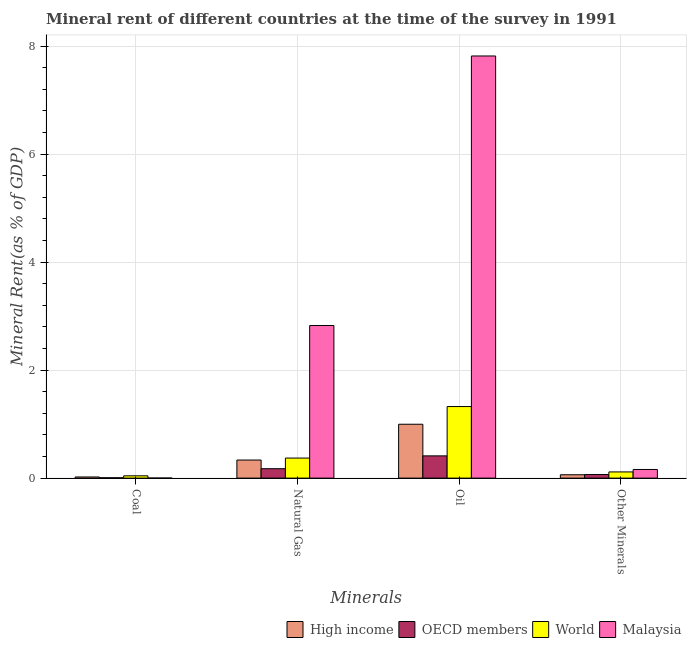How many groups of bars are there?
Give a very brief answer. 4. What is the label of the 3rd group of bars from the left?
Offer a terse response. Oil. What is the  rent of other minerals in World?
Offer a terse response. 0.11. Across all countries, what is the maximum  rent of other minerals?
Offer a terse response. 0.16. Across all countries, what is the minimum coal rent?
Your answer should be very brief. 0. What is the total  rent of other minerals in the graph?
Offer a very short reply. 0.4. What is the difference between the  rent of other minerals in OECD members and that in Malaysia?
Make the answer very short. -0.09. What is the difference between the natural gas rent in High income and the oil rent in World?
Keep it short and to the point. -0.99. What is the average natural gas rent per country?
Provide a succinct answer. 0.93. What is the difference between the coal rent and natural gas rent in World?
Keep it short and to the point. -0.33. What is the ratio of the coal rent in OECD members to that in High income?
Ensure brevity in your answer.  0.32. Is the natural gas rent in OECD members less than that in High income?
Your answer should be compact. Yes. Is the difference between the oil rent in OECD members and World greater than the difference between the  rent of other minerals in OECD members and World?
Ensure brevity in your answer.  No. What is the difference between the highest and the second highest coal rent?
Your answer should be very brief. 0.02. What is the difference between the highest and the lowest oil rent?
Offer a terse response. 7.41. Is the sum of the coal rent in OECD members and World greater than the maximum oil rent across all countries?
Offer a terse response. No. What does the 2nd bar from the right in Coal represents?
Your answer should be compact. World. Is it the case that in every country, the sum of the coal rent and natural gas rent is greater than the oil rent?
Keep it short and to the point. No. How many bars are there?
Provide a succinct answer. 16. How many countries are there in the graph?
Your answer should be very brief. 4. What is the difference between two consecutive major ticks on the Y-axis?
Your response must be concise. 2. Does the graph contain grids?
Provide a short and direct response. Yes. How are the legend labels stacked?
Provide a succinct answer. Horizontal. What is the title of the graph?
Your answer should be compact. Mineral rent of different countries at the time of the survey in 1991. Does "Mongolia" appear as one of the legend labels in the graph?
Provide a succinct answer. No. What is the label or title of the X-axis?
Offer a terse response. Minerals. What is the label or title of the Y-axis?
Ensure brevity in your answer.  Mineral Rent(as % of GDP). What is the Mineral Rent(as % of GDP) in High income in Coal?
Offer a very short reply. 0.02. What is the Mineral Rent(as % of GDP) of OECD members in Coal?
Your answer should be very brief. 0.01. What is the Mineral Rent(as % of GDP) in World in Coal?
Provide a short and direct response. 0.04. What is the Mineral Rent(as % of GDP) of Malaysia in Coal?
Give a very brief answer. 0. What is the Mineral Rent(as % of GDP) in High income in Natural Gas?
Offer a terse response. 0.33. What is the Mineral Rent(as % of GDP) of OECD members in Natural Gas?
Give a very brief answer. 0.17. What is the Mineral Rent(as % of GDP) in World in Natural Gas?
Keep it short and to the point. 0.37. What is the Mineral Rent(as % of GDP) in Malaysia in Natural Gas?
Your answer should be compact. 2.83. What is the Mineral Rent(as % of GDP) of High income in Oil?
Make the answer very short. 1. What is the Mineral Rent(as % of GDP) of OECD members in Oil?
Your answer should be compact. 0.41. What is the Mineral Rent(as % of GDP) of World in Oil?
Make the answer very short. 1.33. What is the Mineral Rent(as % of GDP) in Malaysia in Oil?
Give a very brief answer. 7.82. What is the Mineral Rent(as % of GDP) in High income in Other Minerals?
Your response must be concise. 0.06. What is the Mineral Rent(as % of GDP) in OECD members in Other Minerals?
Provide a succinct answer. 0.07. What is the Mineral Rent(as % of GDP) of World in Other Minerals?
Offer a terse response. 0.11. What is the Mineral Rent(as % of GDP) in Malaysia in Other Minerals?
Your answer should be very brief. 0.16. Across all Minerals, what is the maximum Mineral Rent(as % of GDP) in High income?
Ensure brevity in your answer.  1. Across all Minerals, what is the maximum Mineral Rent(as % of GDP) in OECD members?
Ensure brevity in your answer.  0.41. Across all Minerals, what is the maximum Mineral Rent(as % of GDP) in World?
Ensure brevity in your answer.  1.33. Across all Minerals, what is the maximum Mineral Rent(as % of GDP) in Malaysia?
Your answer should be compact. 7.82. Across all Minerals, what is the minimum Mineral Rent(as % of GDP) of High income?
Provide a succinct answer. 0.02. Across all Minerals, what is the minimum Mineral Rent(as % of GDP) of OECD members?
Offer a very short reply. 0.01. Across all Minerals, what is the minimum Mineral Rent(as % of GDP) of World?
Your answer should be very brief. 0.04. Across all Minerals, what is the minimum Mineral Rent(as % of GDP) of Malaysia?
Your response must be concise. 0. What is the total Mineral Rent(as % of GDP) in High income in the graph?
Provide a short and direct response. 1.42. What is the total Mineral Rent(as % of GDP) in OECD members in the graph?
Offer a terse response. 0.66. What is the total Mineral Rent(as % of GDP) of World in the graph?
Provide a succinct answer. 1.85. What is the total Mineral Rent(as % of GDP) of Malaysia in the graph?
Make the answer very short. 10.81. What is the difference between the Mineral Rent(as % of GDP) in High income in Coal and that in Natural Gas?
Ensure brevity in your answer.  -0.31. What is the difference between the Mineral Rent(as % of GDP) in OECD members in Coal and that in Natural Gas?
Offer a very short reply. -0.17. What is the difference between the Mineral Rent(as % of GDP) in World in Coal and that in Natural Gas?
Provide a short and direct response. -0.33. What is the difference between the Mineral Rent(as % of GDP) in Malaysia in Coal and that in Natural Gas?
Ensure brevity in your answer.  -2.83. What is the difference between the Mineral Rent(as % of GDP) of High income in Coal and that in Oil?
Provide a short and direct response. -0.98. What is the difference between the Mineral Rent(as % of GDP) of OECD members in Coal and that in Oil?
Provide a succinct answer. -0.41. What is the difference between the Mineral Rent(as % of GDP) in World in Coal and that in Oil?
Offer a terse response. -1.28. What is the difference between the Mineral Rent(as % of GDP) in Malaysia in Coal and that in Oil?
Offer a terse response. -7.82. What is the difference between the Mineral Rent(as % of GDP) of High income in Coal and that in Other Minerals?
Your answer should be very brief. -0.04. What is the difference between the Mineral Rent(as % of GDP) in OECD members in Coal and that in Other Minerals?
Offer a terse response. -0.06. What is the difference between the Mineral Rent(as % of GDP) of World in Coal and that in Other Minerals?
Your answer should be compact. -0.07. What is the difference between the Mineral Rent(as % of GDP) in Malaysia in Coal and that in Other Minerals?
Your answer should be compact. -0.16. What is the difference between the Mineral Rent(as % of GDP) in High income in Natural Gas and that in Oil?
Your answer should be compact. -0.66. What is the difference between the Mineral Rent(as % of GDP) of OECD members in Natural Gas and that in Oil?
Provide a short and direct response. -0.24. What is the difference between the Mineral Rent(as % of GDP) in World in Natural Gas and that in Oil?
Your answer should be compact. -0.95. What is the difference between the Mineral Rent(as % of GDP) in Malaysia in Natural Gas and that in Oil?
Make the answer very short. -4.99. What is the difference between the Mineral Rent(as % of GDP) in High income in Natural Gas and that in Other Minerals?
Make the answer very short. 0.27. What is the difference between the Mineral Rent(as % of GDP) of OECD members in Natural Gas and that in Other Minerals?
Provide a succinct answer. 0.11. What is the difference between the Mineral Rent(as % of GDP) in World in Natural Gas and that in Other Minerals?
Give a very brief answer. 0.26. What is the difference between the Mineral Rent(as % of GDP) in Malaysia in Natural Gas and that in Other Minerals?
Keep it short and to the point. 2.67. What is the difference between the Mineral Rent(as % of GDP) of High income in Oil and that in Other Minerals?
Make the answer very short. 0.94. What is the difference between the Mineral Rent(as % of GDP) in OECD members in Oil and that in Other Minerals?
Your answer should be very brief. 0.35. What is the difference between the Mineral Rent(as % of GDP) of World in Oil and that in Other Minerals?
Give a very brief answer. 1.21. What is the difference between the Mineral Rent(as % of GDP) of Malaysia in Oil and that in Other Minerals?
Keep it short and to the point. 7.66. What is the difference between the Mineral Rent(as % of GDP) of High income in Coal and the Mineral Rent(as % of GDP) of OECD members in Natural Gas?
Keep it short and to the point. -0.15. What is the difference between the Mineral Rent(as % of GDP) of High income in Coal and the Mineral Rent(as % of GDP) of World in Natural Gas?
Offer a very short reply. -0.35. What is the difference between the Mineral Rent(as % of GDP) of High income in Coal and the Mineral Rent(as % of GDP) of Malaysia in Natural Gas?
Provide a short and direct response. -2.81. What is the difference between the Mineral Rent(as % of GDP) of OECD members in Coal and the Mineral Rent(as % of GDP) of World in Natural Gas?
Your answer should be compact. -0.36. What is the difference between the Mineral Rent(as % of GDP) in OECD members in Coal and the Mineral Rent(as % of GDP) in Malaysia in Natural Gas?
Provide a short and direct response. -2.82. What is the difference between the Mineral Rent(as % of GDP) in World in Coal and the Mineral Rent(as % of GDP) in Malaysia in Natural Gas?
Ensure brevity in your answer.  -2.78. What is the difference between the Mineral Rent(as % of GDP) of High income in Coal and the Mineral Rent(as % of GDP) of OECD members in Oil?
Ensure brevity in your answer.  -0.39. What is the difference between the Mineral Rent(as % of GDP) in High income in Coal and the Mineral Rent(as % of GDP) in World in Oil?
Keep it short and to the point. -1.3. What is the difference between the Mineral Rent(as % of GDP) in High income in Coal and the Mineral Rent(as % of GDP) in Malaysia in Oil?
Ensure brevity in your answer.  -7.8. What is the difference between the Mineral Rent(as % of GDP) of OECD members in Coal and the Mineral Rent(as % of GDP) of World in Oil?
Keep it short and to the point. -1.32. What is the difference between the Mineral Rent(as % of GDP) of OECD members in Coal and the Mineral Rent(as % of GDP) of Malaysia in Oil?
Ensure brevity in your answer.  -7.81. What is the difference between the Mineral Rent(as % of GDP) of World in Coal and the Mineral Rent(as % of GDP) of Malaysia in Oil?
Your answer should be compact. -7.78. What is the difference between the Mineral Rent(as % of GDP) in High income in Coal and the Mineral Rent(as % of GDP) in OECD members in Other Minerals?
Provide a short and direct response. -0.05. What is the difference between the Mineral Rent(as % of GDP) of High income in Coal and the Mineral Rent(as % of GDP) of World in Other Minerals?
Make the answer very short. -0.09. What is the difference between the Mineral Rent(as % of GDP) of High income in Coal and the Mineral Rent(as % of GDP) of Malaysia in Other Minerals?
Give a very brief answer. -0.14. What is the difference between the Mineral Rent(as % of GDP) in OECD members in Coal and the Mineral Rent(as % of GDP) in World in Other Minerals?
Provide a short and direct response. -0.11. What is the difference between the Mineral Rent(as % of GDP) in OECD members in Coal and the Mineral Rent(as % of GDP) in Malaysia in Other Minerals?
Ensure brevity in your answer.  -0.15. What is the difference between the Mineral Rent(as % of GDP) of World in Coal and the Mineral Rent(as % of GDP) of Malaysia in Other Minerals?
Your answer should be compact. -0.12. What is the difference between the Mineral Rent(as % of GDP) of High income in Natural Gas and the Mineral Rent(as % of GDP) of OECD members in Oil?
Keep it short and to the point. -0.08. What is the difference between the Mineral Rent(as % of GDP) of High income in Natural Gas and the Mineral Rent(as % of GDP) of World in Oil?
Give a very brief answer. -0.99. What is the difference between the Mineral Rent(as % of GDP) of High income in Natural Gas and the Mineral Rent(as % of GDP) of Malaysia in Oil?
Your answer should be compact. -7.48. What is the difference between the Mineral Rent(as % of GDP) of OECD members in Natural Gas and the Mineral Rent(as % of GDP) of World in Oil?
Offer a very short reply. -1.15. What is the difference between the Mineral Rent(as % of GDP) of OECD members in Natural Gas and the Mineral Rent(as % of GDP) of Malaysia in Oil?
Provide a succinct answer. -7.64. What is the difference between the Mineral Rent(as % of GDP) of World in Natural Gas and the Mineral Rent(as % of GDP) of Malaysia in Oil?
Give a very brief answer. -7.45. What is the difference between the Mineral Rent(as % of GDP) of High income in Natural Gas and the Mineral Rent(as % of GDP) of OECD members in Other Minerals?
Provide a succinct answer. 0.27. What is the difference between the Mineral Rent(as % of GDP) of High income in Natural Gas and the Mineral Rent(as % of GDP) of World in Other Minerals?
Offer a terse response. 0.22. What is the difference between the Mineral Rent(as % of GDP) of High income in Natural Gas and the Mineral Rent(as % of GDP) of Malaysia in Other Minerals?
Your response must be concise. 0.17. What is the difference between the Mineral Rent(as % of GDP) in OECD members in Natural Gas and the Mineral Rent(as % of GDP) in World in Other Minerals?
Provide a short and direct response. 0.06. What is the difference between the Mineral Rent(as % of GDP) of OECD members in Natural Gas and the Mineral Rent(as % of GDP) of Malaysia in Other Minerals?
Your answer should be compact. 0.01. What is the difference between the Mineral Rent(as % of GDP) in World in Natural Gas and the Mineral Rent(as % of GDP) in Malaysia in Other Minerals?
Your answer should be compact. 0.21. What is the difference between the Mineral Rent(as % of GDP) of High income in Oil and the Mineral Rent(as % of GDP) of OECD members in Other Minerals?
Ensure brevity in your answer.  0.93. What is the difference between the Mineral Rent(as % of GDP) in High income in Oil and the Mineral Rent(as % of GDP) in World in Other Minerals?
Give a very brief answer. 0.88. What is the difference between the Mineral Rent(as % of GDP) in High income in Oil and the Mineral Rent(as % of GDP) in Malaysia in Other Minerals?
Ensure brevity in your answer.  0.84. What is the difference between the Mineral Rent(as % of GDP) in OECD members in Oil and the Mineral Rent(as % of GDP) in World in Other Minerals?
Your answer should be very brief. 0.3. What is the difference between the Mineral Rent(as % of GDP) in OECD members in Oil and the Mineral Rent(as % of GDP) in Malaysia in Other Minerals?
Offer a terse response. 0.25. What is the difference between the Mineral Rent(as % of GDP) of World in Oil and the Mineral Rent(as % of GDP) of Malaysia in Other Minerals?
Provide a succinct answer. 1.17. What is the average Mineral Rent(as % of GDP) of High income per Minerals?
Provide a succinct answer. 0.35. What is the average Mineral Rent(as % of GDP) in OECD members per Minerals?
Your answer should be very brief. 0.16. What is the average Mineral Rent(as % of GDP) in World per Minerals?
Keep it short and to the point. 0.46. What is the average Mineral Rent(as % of GDP) of Malaysia per Minerals?
Provide a short and direct response. 2.7. What is the difference between the Mineral Rent(as % of GDP) of High income and Mineral Rent(as % of GDP) of OECD members in Coal?
Keep it short and to the point. 0.01. What is the difference between the Mineral Rent(as % of GDP) in High income and Mineral Rent(as % of GDP) in World in Coal?
Offer a terse response. -0.02. What is the difference between the Mineral Rent(as % of GDP) of High income and Mineral Rent(as % of GDP) of Malaysia in Coal?
Your answer should be very brief. 0.02. What is the difference between the Mineral Rent(as % of GDP) in OECD members and Mineral Rent(as % of GDP) in World in Coal?
Your answer should be compact. -0.04. What is the difference between the Mineral Rent(as % of GDP) of OECD members and Mineral Rent(as % of GDP) of Malaysia in Coal?
Your response must be concise. 0.01. What is the difference between the Mineral Rent(as % of GDP) of World and Mineral Rent(as % of GDP) of Malaysia in Coal?
Your answer should be very brief. 0.04. What is the difference between the Mineral Rent(as % of GDP) of High income and Mineral Rent(as % of GDP) of OECD members in Natural Gas?
Offer a terse response. 0.16. What is the difference between the Mineral Rent(as % of GDP) in High income and Mineral Rent(as % of GDP) in World in Natural Gas?
Make the answer very short. -0.04. What is the difference between the Mineral Rent(as % of GDP) of High income and Mineral Rent(as % of GDP) of Malaysia in Natural Gas?
Provide a short and direct response. -2.49. What is the difference between the Mineral Rent(as % of GDP) of OECD members and Mineral Rent(as % of GDP) of World in Natural Gas?
Make the answer very short. -0.2. What is the difference between the Mineral Rent(as % of GDP) in OECD members and Mineral Rent(as % of GDP) in Malaysia in Natural Gas?
Provide a succinct answer. -2.65. What is the difference between the Mineral Rent(as % of GDP) of World and Mineral Rent(as % of GDP) of Malaysia in Natural Gas?
Offer a very short reply. -2.46. What is the difference between the Mineral Rent(as % of GDP) in High income and Mineral Rent(as % of GDP) in OECD members in Oil?
Give a very brief answer. 0.59. What is the difference between the Mineral Rent(as % of GDP) of High income and Mineral Rent(as % of GDP) of World in Oil?
Offer a terse response. -0.33. What is the difference between the Mineral Rent(as % of GDP) in High income and Mineral Rent(as % of GDP) in Malaysia in Oil?
Provide a short and direct response. -6.82. What is the difference between the Mineral Rent(as % of GDP) in OECD members and Mineral Rent(as % of GDP) in World in Oil?
Your answer should be very brief. -0.91. What is the difference between the Mineral Rent(as % of GDP) in OECD members and Mineral Rent(as % of GDP) in Malaysia in Oil?
Make the answer very short. -7.41. What is the difference between the Mineral Rent(as % of GDP) in World and Mineral Rent(as % of GDP) in Malaysia in Oil?
Your answer should be compact. -6.49. What is the difference between the Mineral Rent(as % of GDP) of High income and Mineral Rent(as % of GDP) of OECD members in Other Minerals?
Your answer should be very brief. -0. What is the difference between the Mineral Rent(as % of GDP) of High income and Mineral Rent(as % of GDP) of World in Other Minerals?
Give a very brief answer. -0.05. What is the difference between the Mineral Rent(as % of GDP) in High income and Mineral Rent(as % of GDP) in Malaysia in Other Minerals?
Give a very brief answer. -0.1. What is the difference between the Mineral Rent(as % of GDP) in OECD members and Mineral Rent(as % of GDP) in World in Other Minerals?
Offer a terse response. -0.05. What is the difference between the Mineral Rent(as % of GDP) of OECD members and Mineral Rent(as % of GDP) of Malaysia in Other Minerals?
Keep it short and to the point. -0.09. What is the difference between the Mineral Rent(as % of GDP) of World and Mineral Rent(as % of GDP) of Malaysia in Other Minerals?
Your answer should be compact. -0.05. What is the ratio of the Mineral Rent(as % of GDP) in High income in Coal to that in Natural Gas?
Make the answer very short. 0.06. What is the ratio of the Mineral Rent(as % of GDP) in OECD members in Coal to that in Natural Gas?
Provide a short and direct response. 0.04. What is the ratio of the Mineral Rent(as % of GDP) in World in Coal to that in Natural Gas?
Make the answer very short. 0.11. What is the ratio of the Mineral Rent(as % of GDP) of Malaysia in Coal to that in Natural Gas?
Ensure brevity in your answer.  0. What is the ratio of the Mineral Rent(as % of GDP) of High income in Coal to that in Oil?
Give a very brief answer. 0.02. What is the ratio of the Mineral Rent(as % of GDP) in OECD members in Coal to that in Oil?
Keep it short and to the point. 0.02. What is the ratio of the Mineral Rent(as % of GDP) of World in Coal to that in Oil?
Ensure brevity in your answer.  0.03. What is the ratio of the Mineral Rent(as % of GDP) in Malaysia in Coal to that in Oil?
Make the answer very short. 0. What is the ratio of the Mineral Rent(as % of GDP) in High income in Coal to that in Other Minerals?
Provide a short and direct response. 0.34. What is the ratio of the Mineral Rent(as % of GDP) of OECD members in Coal to that in Other Minerals?
Your response must be concise. 0.1. What is the ratio of the Mineral Rent(as % of GDP) of World in Coal to that in Other Minerals?
Provide a short and direct response. 0.37. What is the ratio of the Mineral Rent(as % of GDP) of Malaysia in Coal to that in Other Minerals?
Make the answer very short. 0.01. What is the ratio of the Mineral Rent(as % of GDP) in High income in Natural Gas to that in Oil?
Offer a terse response. 0.34. What is the ratio of the Mineral Rent(as % of GDP) of OECD members in Natural Gas to that in Oil?
Keep it short and to the point. 0.42. What is the ratio of the Mineral Rent(as % of GDP) in World in Natural Gas to that in Oil?
Give a very brief answer. 0.28. What is the ratio of the Mineral Rent(as % of GDP) of Malaysia in Natural Gas to that in Oil?
Provide a succinct answer. 0.36. What is the ratio of the Mineral Rent(as % of GDP) of High income in Natural Gas to that in Other Minerals?
Provide a succinct answer. 5.37. What is the ratio of the Mineral Rent(as % of GDP) in OECD members in Natural Gas to that in Other Minerals?
Your answer should be very brief. 2.64. What is the ratio of the Mineral Rent(as % of GDP) in World in Natural Gas to that in Other Minerals?
Make the answer very short. 3.24. What is the ratio of the Mineral Rent(as % of GDP) of Malaysia in Natural Gas to that in Other Minerals?
Offer a very short reply. 17.66. What is the ratio of the Mineral Rent(as % of GDP) of High income in Oil to that in Other Minerals?
Provide a short and direct response. 16.01. What is the ratio of the Mineral Rent(as % of GDP) in OECD members in Oil to that in Other Minerals?
Provide a succinct answer. 6.23. What is the ratio of the Mineral Rent(as % of GDP) of World in Oil to that in Other Minerals?
Your answer should be very brief. 11.56. What is the ratio of the Mineral Rent(as % of GDP) of Malaysia in Oil to that in Other Minerals?
Your answer should be compact. 48.85. What is the difference between the highest and the second highest Mineral Rent(as % of GDP) of High income?
Ensure brevity in your answer.  0.66. What is the difference between the highest and the second highest Mineral Rent(as % of GDP) in OECD members?
Provide a succinct answer. 0.24. What is the difference between the highest and the second highest Mineral Rent(as % of GDP) in World?
Offer a very short reply. 0.95. What is the difference between the highest and the second highest Mineral Rent(as % of GDP) of Malaysia?
Provide a succinct answer. 4.99. What is the difference between the highest and the lowest Mineral Rent(as % of GDP) in High income?
Offer a very short reply. 0.98. What is the difference between the highest and the lowest Mineral Rent(as % of GDP) of OECD members?
Give a very brief answer. 0.41. What is the difference between the highest and the lowest Mineral Rent(as % of GDP) of World?
Make the answer very short. 1.28. What is the difference between the highest and the lowest Mineral Rent(as % of GDP) in Malaysia?
Keep it short and to the point. 7.82. 